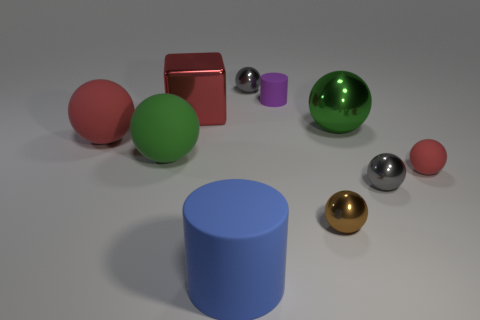Is there any other thing of the same color as the tiny matte cylinder? After examining the image closely, it appears there are no other objects that share the exact same shade and matte finish as the tiny purple cylinder. 